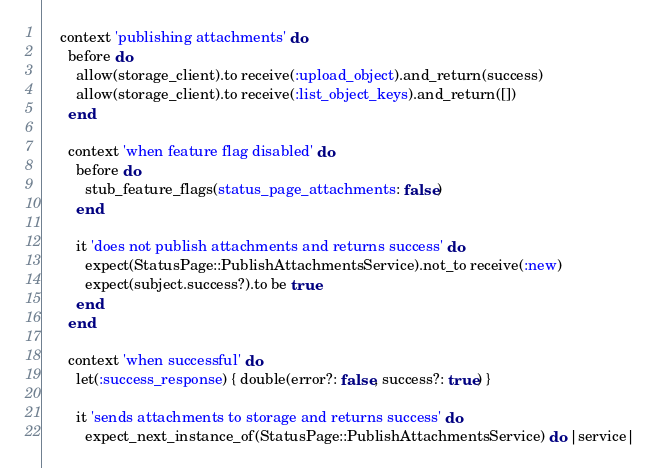<code> <loc_0><loc_0><loc_500><loc_500><_Ruby_>    context 'publishing attachments' do
      before do
        allow(storage_client).to receive(:upload_object).and_return(success)
        allow(storage_client).to receive(:list_object_keys).and_return([])
      end

      context 'when feature flag disabled' do
        before do
          stub_feature_flags(status_page_attachments: false)
        end

        it 'does not publish attachments and returns success' do
          expect(StatusPage::PublishAttachmentsService).not_to receive(:new)
          expect(subject.success?).to be true
        end
      end

      context 'when successful' do
        let(:success_response) { double(error?: false, success?: true) }

        it 'sends attachments to storage and returns success' do
          expect_next_instance_of(StatusPage::PublishAttachmentsService) do |service|</code> 